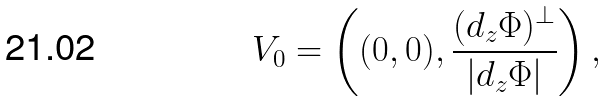Convert formula to latex. <formula><loc_0><loc_0><loc_500><loc_500>V _ { 0 } = \left ( ( 0 , 0 ) , \frac { ( d _ { z } \Phi ) ^ { \perp } } { | d _ { z } \Phi | } \right ) ,</formula> 